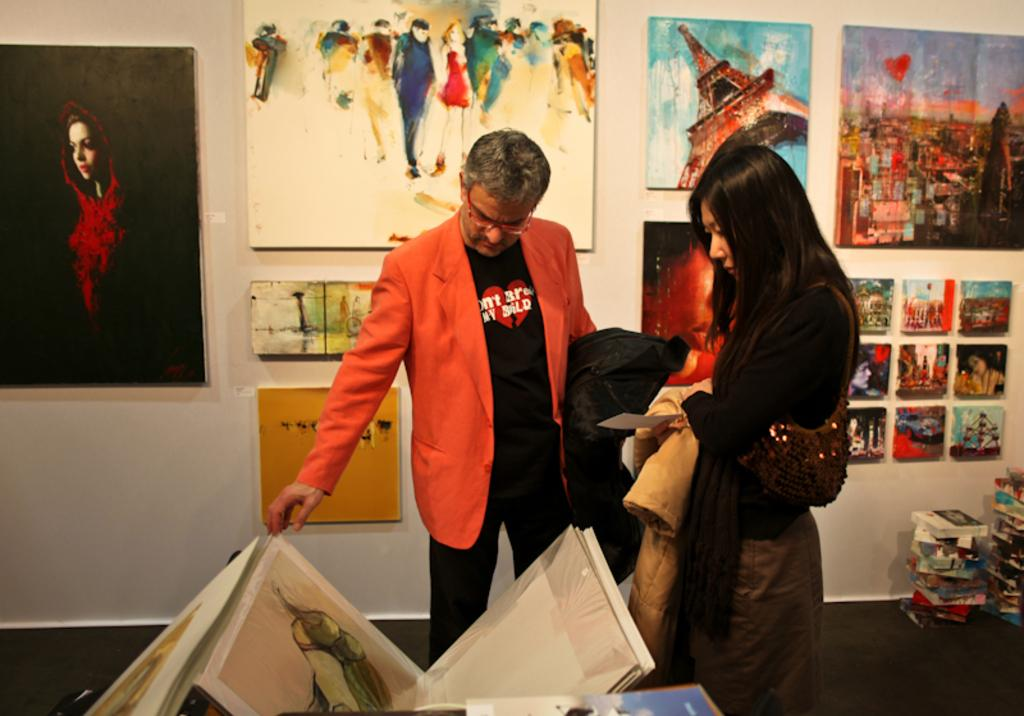What can be seen on the wall in the image? There are paintings on the wall. What is the woman wearing and holding in the image? The woman is wearing a bag and holding a card. What is the man doing in the image? The man is looking at a painting. Can you identify any other objects in the image? Yes, there are books present. How many girls are standing next to the zebra in the image? There are no girls or zebras present in the image. Is the volcano erupting in the background of the image? There is no volcano present in the image. 